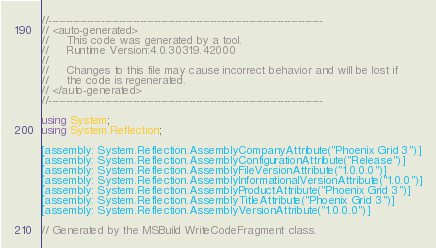<code> <loc_0><loc_0><loc_500><loc_500><_C#_>//------------------------------------------------------------------------------
// <auto-generated>
//     This code was generated by a tool.
//     Runtime Version:4.0.30319.42000
//
//     Changes to this file may cause incorrect behavior and will be lost if
//     the code is regenerated.
// </auto-generated>
//------------------------------------------------------------------------------

using System;
using System.Reflection;

[assembly: System.Reflection.AssemblyCompanyAttribute("Phoenix Grid 3")]
[assembly: System.Reflection.AssemblyConfigurationAttribute("Release")]
[assembly: System.Reflection.AssemblyFileVersionAttribute("1.0.0.0")]
[assembly: System.Reflection.AssemblyInformationalVersionAttribute("1.0.0")]
[assembly: System.Reflection.AssemblyProductAttribute("Phoenix Grid 3")]
[assembly: System.Reflection.AssemblyTitleAttribute("Phoenix Grid 3")]
[assembly: System.Reflection.AssemblyVersionAttribute("1.0.0.0")]

// Generated by the MSBuild WriteCodeFragment class.

</code> 